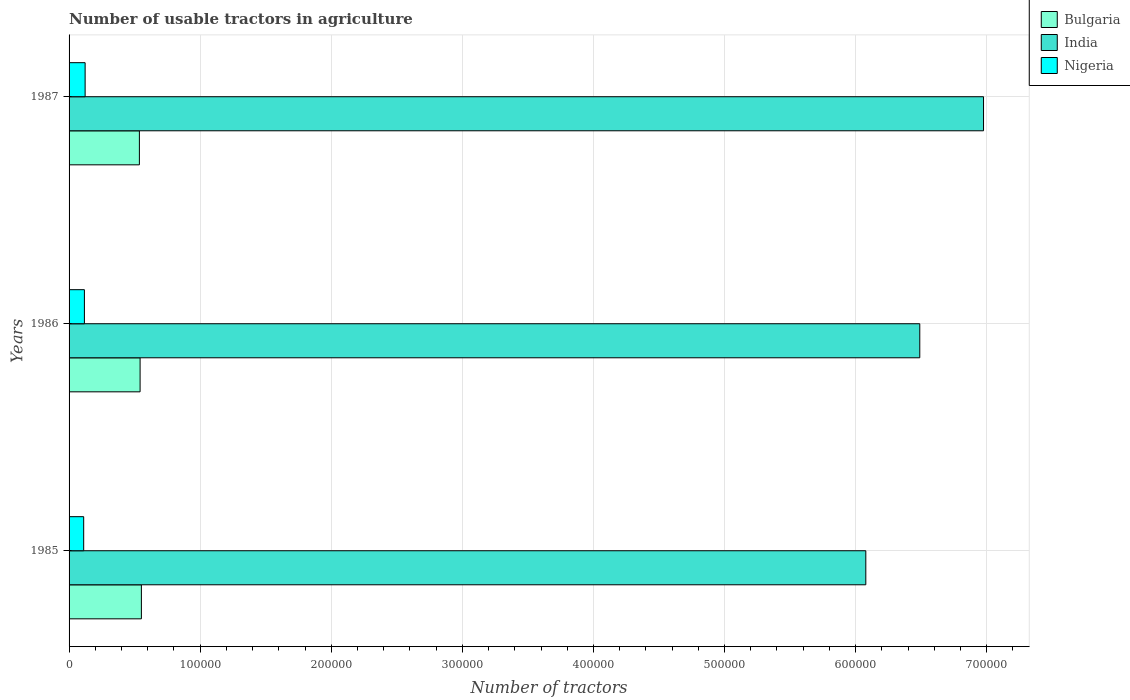How many different coloured bars are there?
Offer a terse response. 3. How many groups of bars are there?
Provide a succinct answer. 3. Are the number of bars per tick equal to the number of legend labels?
Provide a short and direct response. Yes. Are the number of bars on each tick of the Y-axis equal?
Offer a very short reply. Yes. How many bars are there on the 3rd tick from the top?
Provide a succinct answer. 3. What is the label of the 2nd group of bars from the top?
Keep it short and to the point. 1986. In how many cases, is the number of bars for a given year not equal to the number of legend labels?
Keep it short and to the point. 0. What is the number of usable tractors in agriculture in Bulgaria in 1986?
Your answer should be compact. 5.42e+04. Across all years, what is the maximum number of usable tractors in agriculture in Bulgaria?
Provide a short and direct response. 5.52e+04. Across all years, what is the minimum number of usable tractors in agriculture in India?
Ensure brevity in your answer.  6.08e+05. In which year was the number of usable tractors in agriculture in India maximum?
Provide a succinct answer. 1987. In which year was the number of usable tractors in agriculture in Nigeria minimum?
Offer a very short reply. 1985. What is the total number of usable tractors in agriculture in Nigeria in the graph?
Keep it short and to the point. 3.51e+04. What is the difference between the number of usable tractors in agriculture in India in 1985 and that in 1986?
Offer a terse response. -4.12e+04. What is the difference between the number of usable tractors in agriculture in India in 1987 and the number of usable tractors in agriculture in Bulgaria in 1986?
Give a very brief answer. 6.43e+05. What is the average number of usable tractors in agriculture in India per year?
Offer a very short reply. 6.51e+05. In the year 1987, what is the difference between the number of usable tractors in agriculture in Nigeria and number of usable tractors in agriculture in Bulgaria?
Keep it short and to the point. -4.14e+04. What is the ratio of the number of usable tractors in agriculture in India in 1985 to that in 1987?
Your answer should be compact. 0.87. Is the number of usable tractors in agriculture in Nigeria in 1985 less than that in 1987?
Keep it short and to the point. Yes. Is the difference between the number of usable tractors in agriculture in Nigeria in 1985 and 1986 greater than the difference between the number of usable tractors in agriculture in Bulgaria in 1985 and 1986?
Keep it short and to the point. No. What is the difference between the highest and the second highest number of usable tractors in agriculture in India?
Give a very brief answer. 4.86e+04. What is the difference between the highest and the lowest number of usable tractors in agriculture in Nigeria?
Give a very brief answer. 1100. What does the 1st bar from the top in 1985 represents?
Your response must be concise. Nigeria. What does the 2nd bar from the bottom in 1985 represents?
Ensure brevity in your answer.  India. Is it the case that in every year, the sum of the number of usable tractors in agriculture in India and number of usable tractors in agriculture in Bulgaria is greater than the number of usable tractors in agriculture in Nigeria?
Give a very brief answer. Yes. What is the difference between two consecutive major ticks on the X-axis?
Offer a terse response. 1.00e+05. Does the graph contain grids?
Offer a very short reply. Yes. What is the title of the graph?
Offer a terse response. Number of usable tractors in agriculture. Does "Namibia" appear as one of the legend labels in the graph?
Your answer should be compact. No. What is the label or title of the X-axis?
Your answer should be very brief. Number of tractors. What is the Number of tractors of Bulgaria in 1985?
Keep it short and to the point. 5.52e+04. What is the Number of tractors in India in 1985?
Your answer should be very brief. 6.08e+05. What is the Number of tractors in Nigeria in 1985?
Keep it short and to the point. 1.12e+04. What is the Number of tractors of Bulgaria in 1986?
Provide a short and direct response. 5.42e+04. What is the Number of tractors in India in 1986?
Your answer should be very brief. 6.49e+05. What is the Number of tractors in Nigeria in 1986?
Give a very brief answer. 1.17e+04. What is the Number of tractors of Bulgaria in 1987?
Offer a terse response. 5.36e+04. What is the Number of tractors of India in 1987?
Provide a succinct answer. 6.98e+05. What is the Number of tractors in Nigeria in 1987?
Keep it short and to the point. 1.22e+04. Across all years, what is the maximum Number of tractors of Bulgaria?
Offer a very short reply. 5.52e+04. Across all years, what is the maximum Number of tractors of India?
Offer a very short reply. 6.98e+05. Across all years, what is the maximum Number of tractors of Nigeria?
Your answer should be compact. 1.22e+04. Across all years, what is the minimum Number of tractors of Bulgaria?
Your response must be concise. 5.36e+04. Across all years, what is the minimum Number of tractors of India?
Make the answer very short. 6.08e+05. Across all years, what is the minimum Number of tractors of Nigeria?
Ensure brevity in your answer.  1.12e+04. What is the total Number of tractors in Bulgaria in the graph?
Give a very brief answer. 1.63e+05. What is the total Number of tractors in India in the graph?
Give a very brief answer. 1.95e+06. What is the total Number of tractors of Nigeria in the graph?
Provide a short and direct response. 3.51e+04. What is the difference between the Number of tractors in Bulgaria in 1985 and that in 1986?
Provide a succinct answer. 981. What is the difference between the Number of tractors in India in 1985 and that in 1986?
Provide a short and direct response. -4.12e+04. What is the difference between the Number of tractors of Nigeria in 1985 and that in 1986?
Offer a very short reply. -550. What is the difference between the Number of tractors in Bulgaria in 1985 and that in 1987?
Your answer should be compact. 1521. What is the difference between the Number of tractors in India in 1985 and that in 1987?
Your answer should be very brief. -8.98e+04. What is the difference between the Number of tractors in Nigeria in 1985 and that in 1987?
Your answer should be very brief. -1100. What is the difference between the Number of tractors of Bulgaria in 1986 and that in 1987?
Your answer should be very brief. 540. What is the difference between the Number of tractors in India in 1986 and that in 1987?
Offer a very short reply. -4.86e+04. What is the difference between the Number of tractors in Nigeria in 1986 and that in 1987?
Offer a terse response. -550. What is the difference between the Number of tractors of Bulgaria in 1985 and the Number of tractors of India in 1986?
Your answer should be compact. -5.94e+05. What is the difference between the Number of tractors in Bulgaria in 1985 and the Number of tractors in Nigeria in 1986?
Offer a very short reply. 4.35e+04. What is the difference between the Number of tractors of India in 1985 and the Number of tractors of Nigeria in 1986?
Give a very brief answer. 5.96e+05. What is the difference between the Number of tractors in Bulgaria in 1985 and the Number of tractors in India in 1987?
Provide a short and direct response. -6.42e+05. What is the difference between the Number of tractors of Bulgaria in 1985 and the Number of tractors of Nigeria in 1987?
Make the answer very short. 4.29e+04. What is the difference between the Number of tractors in India in 1985 and the Number of tractors in Nigeria in 1987?
Give a very brief answer. 5.96e+05. What is the difference between the Number of tractors of Bulgaria in 1986 and the Number of tractors of India in 1987?
Your answer should be compact. -6.43e+05. What is the difference between the Number of tractors in Bulgaria in 1986 and the Number of tractors in Nigeria in 1987?
Offer a very short reply. 4.19e+04. What is the difference between the Number of tractors of India in 1986 and the Number of tractors of Nigeria in 1987?
Keep it short and to the point. 6.37e+05. What is the average Number of tractors in Bulgaria per year?
Offer a very short reply. 5.43e+04. What is the average Number of tractors of India per year?
Give a very brief answer. 6.51e+05. What is the average Number of tractors in Nigeria per year?
Your response must be concise. 1.17e+04. In the year 1985, what is the difference between the Number of tractors of Bulgaria and Number of tractors of India?
Offer a very short reply. -5.53e+05. In the year 1985, what is the difference between the Number of tractors in Bulgaria and Number of tractors in Nigeria?
Give a very brief answer. 4.40e+04. In the year 1985, what is the difference between the Number of tractors in India and Number of tractors in Nigeria?
Offer a very short reply. 5.97e+05. In the year 1986, what is the difference between the Number of tractors in Bulgaria and Number of tractors in India?
Your response must be concise. -5.95e+05. In the year 1986, what is the difference between the Number of tractors in Bulgaria and Number of tractors in Nigeria?
Give a very brief answer. 4.25e+04. In the year 1986, what is the difference between the Number of tractors in India and Number of tractors in Nigeria?
Your answer should be very brief. 6.37e+05. In the year 1987, what is the difference between the Number of tractors of Bulgaria and Number of tractors of India?
Make the answer very short. -6.44e+05. In the year 1987, what is the difference between the Number of tractors in Bulgaria and Number of tractors in Nigeria?
Provide a succinct answer. 4.14e+04. In the year 1987, what is the difference between the Number of tractors in India and Number of tractors in Nigeria?
Your answer should be very brief. 6.85e+05. What is the ratio of the Number of tractors of Bulgaria in 1985 to that in 1986?
Keep it short and to the point. 1.02. What is the ratio of the Number of tractors of India in 1985 to that in 1986?
Offer a terse response. 0.94. What is the ratio of the Number of tractors of Nigeria in 1985 to that in 1986?
Your answer should be compact. 0.95. What is the ratio of the Number of tractors in Bulgaria in 1985 to that in 1987?
Make the answer very short. 1.03. What is the ratio of the Number of tractors in India in 1985 to that in 1987?
Provide a short and direct response. 0.87. What is the ratio of the Number of tractors of Nigeria in 1985 to that in 1987?
Ensure brevity in your answer.  0.91. What is the ratio of the Number of tractors of Bulgaria in 1986 to that in 1987?
Your answer should be very brief. 1.01. What is the ratio of the Number of tractors in India in 1986 to that in 1987?
Your answer should be very brief. 0.93. What is the ratio of the Number of tractors in Nigeria in 1986 to that in 1987?
Provide a short and direct response. 0.96. What is the difference between the highest and the second highest Number of tractors in Bulgaria?
Your response must be concise. 981. What is the difference between the highest and the second highest Number of tractors of India?
Give a very brief answer. 4.86e+04. What is the difference between the highest and the second highest Number of tractors in Nigeria?
Offer a very short reply. 550. What is the difference between the highest and the lowest Number of tractors in Bulgaria?
Give a very brief answer. 1521. What is the difference between the highest and the lowest Number of tractors of India?
Keep it short and to the point. 8.98e+04. What is the difference between the highest and the lowest Number of tractors in Nigeria?
Keep it short and to the point. 1100. 